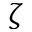Convert formula to latex. <formula><loc_0><loc_0><loc_500><loc_500>\zeta</formula> 